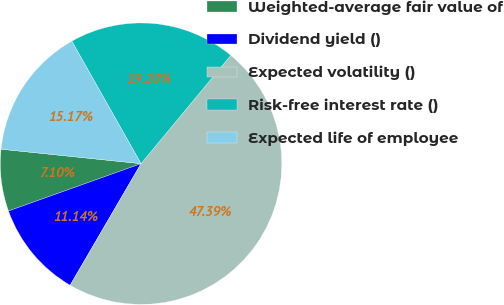Convert chart to OTSL. <chart><loc_0><loc_0><loc_500><loc_500><pie_chart><fcel>Weighted-average fair value of<fcel>Dividend yield ()<fcel>Expected volatility ()<fcel>Risk-free interest rate ()<fcel>Expected life of employee<nl><fcel>7.1%<fcel>11.14%<fcel>47.39%<fcel>19.2%<fcel>15.17%<nl></chart> 